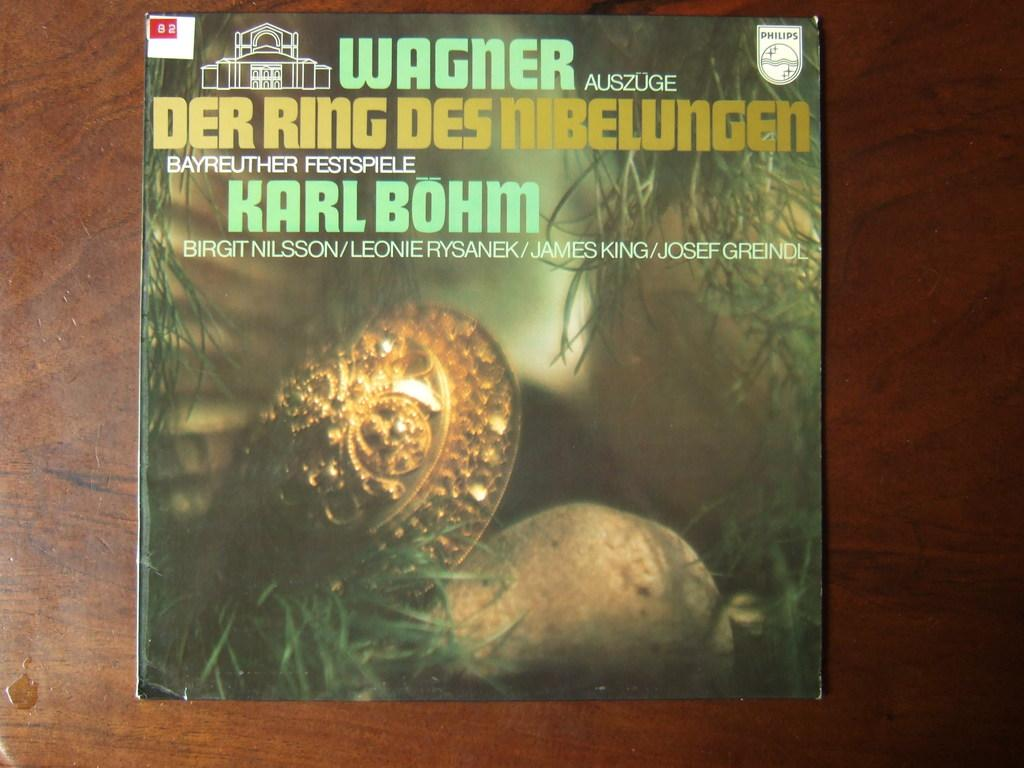<image>
Provide a brief description of the given image. A book on a table has a red printed label with the number 82. 